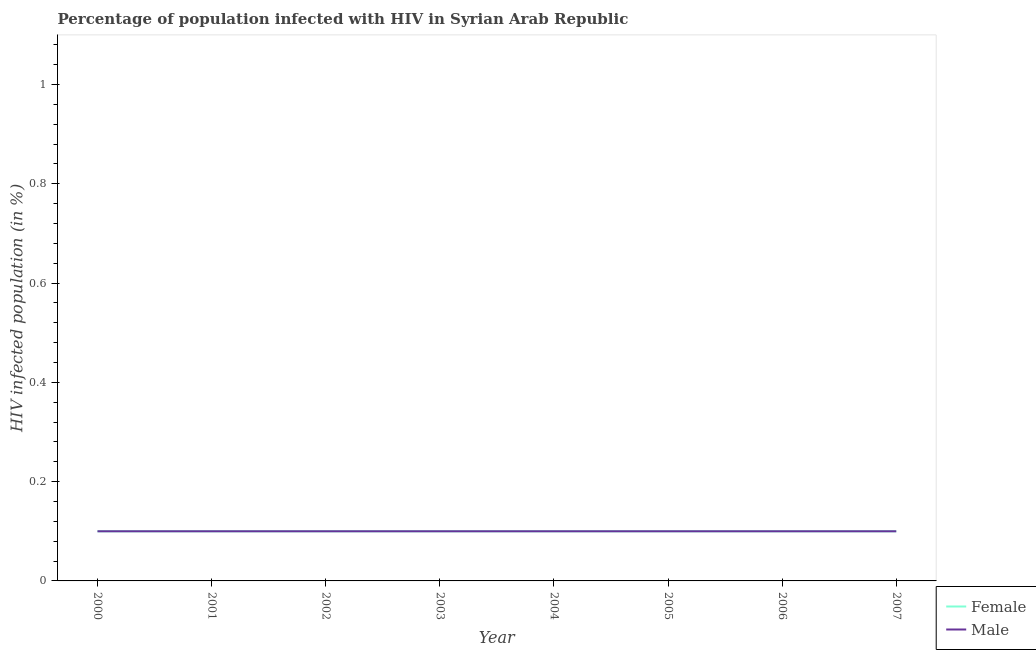How many different coloured lines are there?
Ensure brevity in your answer.  2. Does the line corresponding to percentage of males who are infected with hiv intersect with the line corresponding to percentage of females who are infected with hiv?
Give a very brief answer. Yes. Across all years, what is the minimum percentage of females who are infected with hiv?
Your response must be concise. 0.1. In which year was the percentage of males who are infected with hiv maximum?
Provide a succinct answer. 2000. In which year was the percentage of males who are infected with hiv minimum?
Give a very brief answer. 2000. What is the total percentage of females who are infected with hiv in the graph?
Offer a very short reply. 0.8. What is the difference between the percentage of males who are infected with hiv in 2002 and the percentage of females who are infected with hiv in 2000?
Make the answer very short. 0. What is the average percentage of males who are infected with hiv per year?
Your response must be concise. 0.1. Is the percentage of females who are infected with hiv in 2001 less than that in 2005?
Your answer should be very brief. No. What is the difference between the highest and the second highest percentage of males who are infected with hiv?
Keep it short and to the point. 0. What is the difference between the highest and the lowest percentage of females who are infected with hiv?
Ensure brevity in your answer.  0. How many lines are there?
Keep it short and to the point. 2. Does the graph contain grids?
Ensure brevity in your answer.  No. Where does the legend appear in the graph?
Offer a very short reply. Bottom right. How many legend labels are there?
Ensure brevity in your answer.  2. What is the title of the graph?
Make the answer very short. Percentage of population infected with HIV in Syrian Arab Republic. What is the label or title of the X-axis?
Your answer should be compact. Year. What is the label or title of the Y-axis?
Provide a short and direct response. HIV infected population (in %). What is the HIV infected population (in %) in Female in 2000?
Your answer should be compact. 0.1. What is the HIV infected population (in %) in Female in 2001?
Offer a very short reply. 0.1. What is the HIV infected population (in %) of Male in 2004?
Your response must be concise. 0.1. What is the HIV infected population (in %) in Male in 2005?
Provide a succinct answer. 0.1. What is the HIV infected population (in %) in Female in 2006?
Make the answer very short. 0.1. What is the HIV infected population (in %) in Male in 2006?
Keep it short and to the point. 0.1. What is the HIV infected population (in %) in Female in 2007?
Make the answer very short. 0.1. What is the HIV infected population (in %) of Male in 2007?
Keep it short and to the point. 0.1. Across all years, what is the minimum HIV infected population (in %) of Female?
Offer a terse response. 0.1. What is the total HIV infected population (in %) of Female in the graph?
Offer a terse response. 0.8. What is the difference between the HIV infected population (in %) in Male in 2000 and that in 2002?
Offer a very short reply. 0. What is the difference between the HIV infected population (in %) of Female in 2000 and that in 2003?
Ensure brevity in your answer.  0. What is the difference between the HIV infected population (in %) of Male in 2000 and that in 2003?
Provide a short and direct response. 0. What is the difference between the HIV infected population (in %) of Male in 2000 and that in 2004?
Your answer should be compact. 0. What is the difference between the HIV infected population (in %) in Male in 2000 and that in 2005?
Give a very brief answer. 0. What is the difference between the HIV infected population (in %) in Female in 2000 and that in 2006?
Provide a succinct answer. 0. What is the difference between the HIV infected population (in %) in Male in 2000 and that in 2006?
Offer a very short reply. 0. What is the difference between the HIV infected population (in %) of Female in 2000 and that in 2007?
Ensure brevity in your answer.  0. What is the difference between the HIV infected population (in %) of Female in 2001 and that in 2002?
Ensure brevity in your answer.  0. What is the difference between the HIV infected population (in %) of Female in 2001 and that in 2004?
Give a very brief answer. 0. What is the difference between the HIV infected population (in %) of Female in 2001 and that in 2006?
Keep it short and to the point. 0. What is the difference between the HIV infected population (in %) in Female in 2001 and that in 2007?
Provide a short and direct response. 0. What is the difference between the HIV infected population (in %) in Female in 2002 and that in 2003?
Your answer should be compact. 0. What is the difference between the HIV infected population (in %) in Male in 2002 and that in 2003?
Make the answer very short. 0. What is the difference between the HIV infected population (in %) in Female in 2002 and that in 2004?
Offer a very short reply. 0. What is the difference between the HIV infected population (in %) of Female in 2002 and that in 2005?
Offer a very short reply. 0. What is the difference between the HIV infected population (in %) of Male in 2002 and that in 2005?
Make the answer very short. 0. What is the difference between the HIV infected population (in %) in Male in 2002 and that in 2006?
Make the answer very short. 0. What is the difference between the HIV infected population (in %) of Female in 2002 and that in 2007?
Keep it short and to the point. 0. What is the difference between the HIV infected population (in %) in Male in 2002 and that in 2007?
Offer a terse response. 0. What is the difference between the HIV infected population (in %) of Male in 2003 and that in 2004?
Make the answer very short. 0. What is the difference between the HIV infected population (in %) in Male in 2003 and that in 2005?
Give a very brief answer. 0. What is the difference between the HIV infected population (in %) in Female in 2003 and that in 2006?
Give a very brief answer. 0. What is the difference between the HIV infected population (in %) in Male in 2003 and that in 2007?
Offer a very short reply. 0. What is the difference between the HIV infected population (in %) of Female in 2004 and that in 2007?
Provide a succinct answer. 0. What is the difference between the HIV infected population (in %) in Male in 2004 and that in 2007?
Your answer should be compact. 0. What is the difference between the HIV infected population (in %) in Male in 2005 and that in 2006?
Offer a very short reply. 0. What is the difference between the HIV infected population (in %) in Female in 2005 and that in 2007?
Ensure brevity in your answer.  0. What is the difference between the HIV infected population (in %) in Male in 2005 and that in 2007?
Your response must be concise. 0. What is the difference between the HIV infected population (in %) in Female in 2006 and that in 2007?
Your answer should be very brief. 0. What is the difference between the HIV infected population (in %) of Male in 2006 and that in 2007?
Your response must be concise. 0. What is the difference between the HIV infected population (in %) of Female in 2000 and the HIV infected population (in %) of Male in 2001?
Make the answer very short. 0. What is the difference between the HIV infected population (in %) of Female in 2000 and the HIV infected population (in %) of Male in 2002?
Make the answer very short. 0. What is the difference between the HIV infected population (in %) of Female in 2000 and the HIV infected population (in %) of Male in 2003?
Provide a short and direct response. 0. What is the difference between the HIV infected population (in %) of Female in 2000 and the HIV infected population (in %) of Male in 2006?
Your answer should be compact. 0. What is the difference between the HIV infected population (in %) of Female in 2001 and the HIV infected population (in %) of Male in 2003?
Make the answer very short. 0. What is the difference between the HIV infected population (in %) of Female in 2001 and the HIV infected population (in %) of Male in 2005?
Provide a short and direct response. 0. What is the difference between the HIV infected population (in %) in Female in 2002 and the HIV infected population (in %) in Male in 2003?
Your response must be concise. 0. What is the difference between the HIV infected population (in %) of Female in 2002 and the HIV infected population (in %) of Male in 2006?
Keep it short and to the point. 0. What is the difference between the HIV infected population (in %) in Female in 2002 and the HIV infected population (in %) in Male in 2007?
Offer a very short reply. 0. What is the difference between the HIV infected population (in %) in Female in 2003 and the HIV infected population (in %) in Male in 2005?
Give a very brief answer. 0. What is the difference between the HIV infected population (in %) in Female in 2004 and the HIV infected population (in %) in Male in 2006?
Make the answer very short. 0. What is the difference between the HIV infected population (in %) of Female in 2004 and the HIV infected population (in %) of Male in 2007?
Make the answer very short. 0. What is the difference between the HIV infected population (in %) of Female in 2005 and the HIV infected population (in %) of Male in 2006?
Keep it short and to the point. 0. What is the average HIV infected population (in %) of Female per year?
Give a very brief answer. 0.1. What is the average HIV infected population (in %) in Male per year?
Provide a short and direct response. 0.1. In the year 2001, what is the difference between the HIV infected population (in %) of Female and HIV infected population (in %) of Male?
Ensure brevity in your answer.  0. In the year 2005, what is the difference between the HIV infected population (in %) of Female and HIV infected population (in %) of Male?
Offer a very short reply. 0. In the year 2006, what is the difference between the HIV infected population (in %) in Female and HIV infected population (in %) in Male?
Provide a succinct answer. 0. What is the ratio of the HIV infected population (in %) of Female in 2000 to that in 2001?
Keep it short and to the point. 1. What is the ratio of the HIV infected population (in %) in Male in 2000 to that in 2001?
Your answer should be compact. 1. What is the ratio of the HIV infected population (in %) of Male in 2000 to that in 2002?
Your answer should be very brief. 1. What is the ratio of the HIV infected population (in %) in Female in 2000 to that in 2003?
Your answer should be compact. 1. What is the ratio of the HIV infected population (in %) of Female in 2000 to that in 2005?
Your answer should be compact. 1. What is the ratio of the HIV infected population (in %) of Male in 2000 to that in 2005?
Provide a short and direct response. 1. What is the ratio of the HIV infected population (in %) in Male in 2000 to that in 2007?
Ensure brevity in your answer.  1. What is the ratio of the HIV infected population (in %) of Female in 2001 to that in 2002?
Offer a terse response. 1. What is the ratio of the HIV infected population (in %) of Female in 2001 to that in 2003?
Your response must be concise. 1. What is the ratio of the HIV infected population (in %) in Male in 2001 to that in 2003?
Provide a short and direct response. 1. What is the ratio of the HIV infected population (in %) in Female in 2001 to that in 2004?
Keep it short and to the point. 1. What is the ratio of the HIV infected population (in %) of Male in 2001 to that in 2004?
Ensure brevity in your answer.  1. What is the ratio of the HIV infected population (in %) of Female in 2001 to that in 2005?
Keep it short and to the point. 1. What is the ratio of the HIV infected population (in %) in Female in 2001 to that in 2006?
Keep it short and to the point. 1. What is the ratio of the HIV infected population (in %) of Male in 2001 to that in 2007?
Offer a very short reply. 1. What is the ratio of the HIV infected population (in %) in Female in 2002 to that in 2003?
Your response must be concise. 1. What is the ratio of the HIV infected population (in %) in Female in 2002 to that in 2004?
Make the answer very short. 1. What is the ratio of the HIV infected population (in %) in Male in 2002 to that in 2004?
Your answer should be compact. 1. What is the ratio of the HIV infected population (in %) in Female in 2002 to that in 2005?
Your response must be concise. 1. What is the ratio of the HIV infected population (in %) in Male in 2002 to that in 2006?
Make the answer very short. 1. What is the ratio of the HIV infected population (in %) in Female in 2002 to that in 2007?
Your answer should be compact. 1. What is the ratio of the HIV infected population (in %) in Female in 2003 to that in 2004?
Your answer should be compact. 1. What is the ratio of the HIV infected population (in %) in Male in 2003 to that in 2004?
Keep it short and to the point. 1. What is the ratio of the HIV infected population (in %) in Female in 2003 to that in 2006?
Offer a terse response. 1. What is the ratio of the HIV infected population (in %) of Female in 2003 to that in 2007?
Make the answer very short. 1. What is the ratio of the HIV infected population (in %) of Male in 2003 to that in 2007?
Your answer should be very brief. 1. What is the ratio of the HIV infected population (in %) of Male in 2004 to that in 2005?
Offer a terse response. 1. What is the ratio of the HIV infected population (in %) of Male in 2004 to that in 2007?
Your answer should be compact. 1. What is the ratio of the HIV infected population (in %) in Male in 2005 to that in 2006?
Provide a succinct answer. 1. What is the ratio of the HIV infected population (in %) in Female in 2005 to that in 2007?
Provide a succinct answer. 1. What is the ratio of the HIV infected population (in %) of Male in 2005 to that in 2007?
Your response must be concise. 1. What is the ratio of the HIV infected population (in %) in Male in 2006 to that in 2007?
Your answer should be very brief. 1. What is the difference between the highest and the second highest HIV infected population (in %) in Male?
Give a very brief answer. 0. What is the difference between the highest and the lowest HIV infected population (in %) of Female?
Make the answer very short. 0. What is the difference between the highest and the lowest HIV infected population (in %) of Male?
Your answer should be compact. 0. 